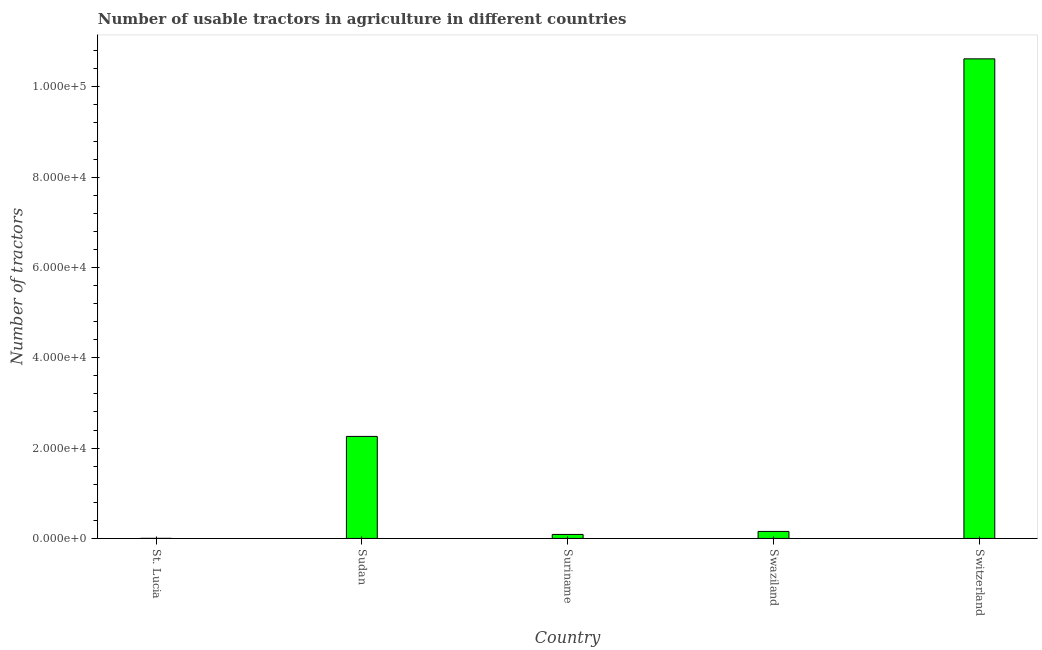Does the graph contain any zero values?
Offer a terse response. No. What is the title of the graph?
Your response must be concise. Number of usable tractors in agriculture in different countries. What is the label or title of the X-axis?
Your response must be concise. Country. What is the label or title of the Y-axis?
Your answer should be very brief. Number of tractors. Across all countries, what is the maximum number of tractors?
Your answer should be compact. 1.06e+05. Across all countries, what is the minimum number of tractors?
Give a very brief answer. 14. In which country was the number of tractors maximum?
Make the answer very short. Switzerland. In which country was the number of tractors minimum?
Provide a succinct answer. St. Lucia. What is the sum of the number of tractors?
Ensure brevity in your answer.  1.31e+05. What is the difference between the number of tractors in Swaziland and Switzerland?
Your response must be concise. -1.05e+05. What is the average number of tractors per country?
Make the answer very short. 2.62e+04. What is the median number of tractors?
Your response must be concise. 1550. What is the ratio of the number of tractors in Sudan to that in Suriname?
Provide a succinct answer. 25.52. What is the difference between the highest and the second highest number of tractors?
Your response must be concise. 8.36e+04. Is the sum of the number of tractors in Sudan and Swaziland greater than the maximum number of tractors across all countries?
Your answer should be very brief. No. What is the difference between the highest and the lowest number of tractors?
Make the answer very short. 1.06e+05. In how many countries, is the number of tractors greater than the average number of tractors taken over all countries?
Offer a terse response. 1. Are all the bars in the graph horizontal?
Offer a terse response. No. What is the difference between two consecutive major ticks on the Y-axis?
Provide a succinct answer. 2.00e+04. What is the Number of tractors in Sudan?
Ensure brevity in your answer.  2.26e+04. What is the Number of tractors in Suriname?
Offer a terse response. 885. What is the Number of tractors of Swaziland?
Offer a very short reply. 1550. What is the Number of tractors of Switzerland?
Ensure brevity in your answer.  1.06e+05. What is the difference between the Number of tractors in St. Lucia and Sudan?
Offer a very short reply. -2.26e+04. What is the difference between the Number of tractors in St. Lucia and Suriname?
Make the answer very short. -871. What is the difference between the Number of tractors in St. Lucia and Swaziland?
Provide a short and direct response. -1536. What is the difference between the Number of tractors in St. Lucia and Switzerland?
Ensure brevity in your answer.  -1.06e+05. What is the difference between the Number of tractors in Sudan and Suriname?
Offer a very short reply. 2.17e+04. What is the difference between the Number of tractors in Sudan and Swaziland?
Make the answer very short. 2.10e+04. What is the difference between the Number of tractors in Sudan and Switzerland?
Give a very brief answer. -8.36e+04. What is the difference between the Number of tractors in Suriname and Swaziland?
Give a very brief answer. -665. What is the difference between the Number of tractors in Suriname and Switzerland?
Your answer should be compact. -1.05e+05. What is the difference between the Number of tractors in Swaziland and Switzerland?
Offer a very short reply. -1.05e+05. What is the ratio of the Number of tractors in St. Lucia to that in Sudan?
Offer a terse response. 0. What is the ratio of the Number of tractors in St. Lucia to that in Suriname?
Keep it short and to the point. 0.02. What is the ratio of the Number of tractors in St. Lucia to that in Swaziland?
Offer a terse response. 0.01. What is the ratio of the Number of tractors in St. Lucia to that in Switzerland?
Your answer should be very brief. 0. What is the ratio of the Number of tractors in Sudan to that in Suriname?
Your answer should be compact. 25.52. What is the ratio of the Number of tractors in Sudan to that in Swaziland?
Your answer should be compact. 14.57. What is the ratio of the Number of tractors in Sudan to that in Switzerland?
Provide a succinct answer. 0.21. What is the ratio of the Number of tractors in Suriname to that in Swaziland?
Ensure brevity in your answer.  0.57. What is the ratio of the Number of tractors in Suriname to that in Switzerland?
Keep it short and to the point. 0.01. What is the ratio of the Number of tractors in Swaziland to that in Switzerland?
Your answer should be very brief. 0.01. 